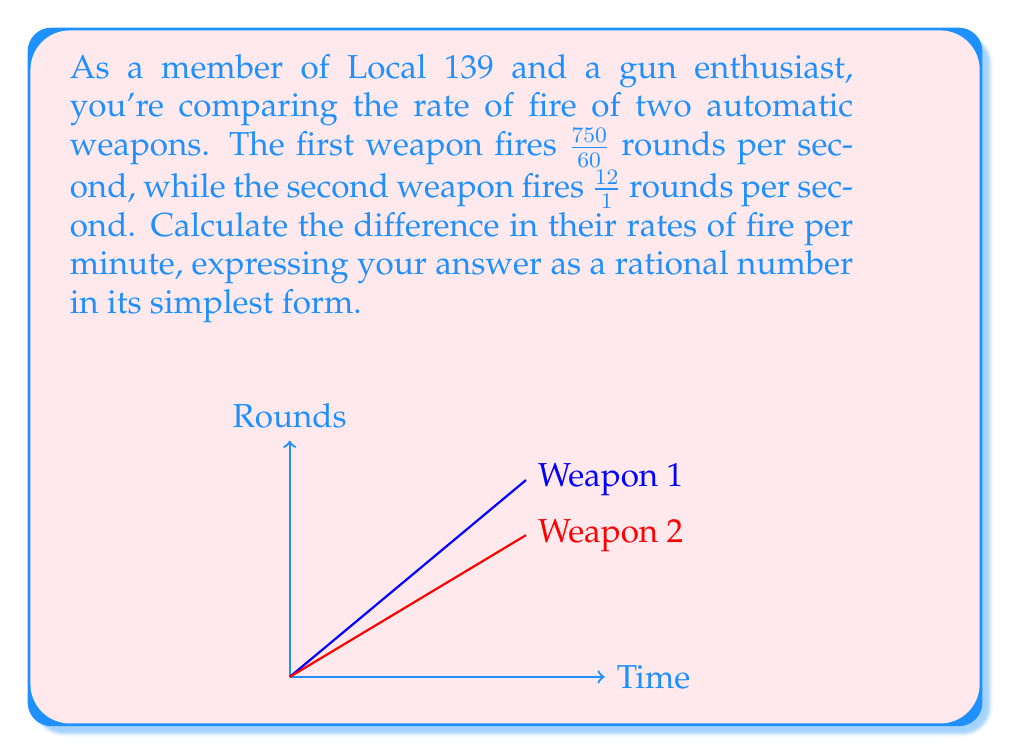Can you answer this question? Let's approach this step-by-step:

1) First, let's convert both rates to rounds per minute:

   Weapon 1: $\frac{750}{60}$ rounds/second
   $$\frac{750}{60} \cdot 60 = 750$$ rounds/minute

   Weapon 2: $\frac{12}{1}$ rounds/second
   $$\frac{12}{1} \cdot 60 = 720$$ rounds/minute

2) Now, let's find the difference:

   $$750 - 720 = 30$$ rounds/minute

3) The difference is already a whole number, which is a rational number in its simplest form.
Answer: $30$ rounds/minute 